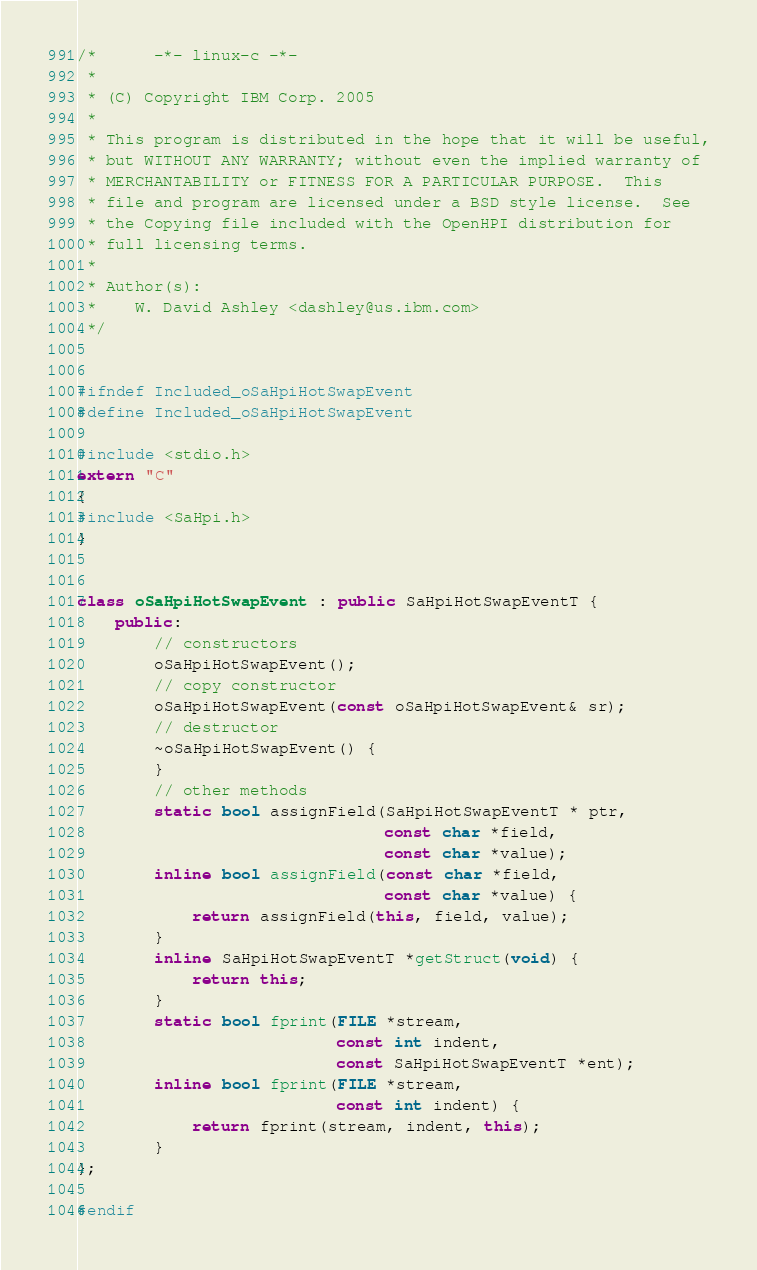<code> <loc_0><loc_0><loc_500><loc_500><_C++_>/*      -*- linux-c -*-
 *
 * (C) Copyright IBM Corp. 2005
 *
 * This program is distributed in the hope that it will be useful,
 * but WITHOUT ANY WARRANTY; without even the implied warranty of
 * MERCHANTABILITY or FITNESS FOR A PARTICULAR PURPOSE.  This
 * file and program are licensed under a BSD style license.  See
 * the Copying file included with the OpenHPI distribution for
 * full licensing terms.
 *
 * Author(s):
 *    W. David Ashley <dashley@us.ibm.com>
 */


#ifndef Included_oSaHpiHotSwapEvent
#define Included_oSaHpiHotSwapEvent

#include <stdio.h>
extern "C"
{
#include <SaHpi.h>
}


class oSaHpiHotSwapEvent : public SaHpiHotSwapEventT {
    public:
        // constructors
        oSaHpiHotSwapEvent();
        // copy constructor
        oSaHpiHotSwapEvent(const oSaHpiHotSwapEvent& sr);
        // destructor
        ~oSaHpiHotSwapEvent() {
        }
        // other methods
        static bool assignField(SaHpiHotSwapEventT * ptr,
                                const char *field,
                                const char *value);
        inline bool assignField(const char *field,
                                const char *value) {
            return assignField(this, field, value);
        }
        inline SaHpiHotSwapEventT *getStruct(void) {
            return this;
        }
        static bool fprint(FILE *stream,
                           const int indent,
                           const SaHpiHotSwapEventT *ent);
        inline bool fprint(FILE *stream,
                           const int indent) {
            return fprint(stream, indent, this);
        }
};

#endif

</code> 